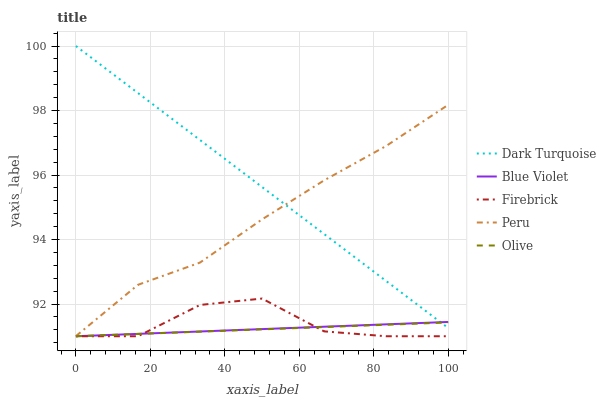Does Firebrick have the minimum area under the curve?
Answer yes or no. No. Does Firebrick have the maximum area under the curve?
Answer yes or no. No. Is Firebrick the smoothest?
Answer yes or no. No. Is Dark Turquoise the roughest?
Answer yes or no. No. Does Dark Turquoise have the lowest value?
Answer yes or no. No. Does Firebrick have the highest value?
Answer yes or no. No. Is Firebrick less than Peru?
Answer yes or no. Yes. Is Peru greater than Blue Violet?
Answer yes or no. Yes. Does Firebrick intersect Peru?
Answer yes or no. No. 